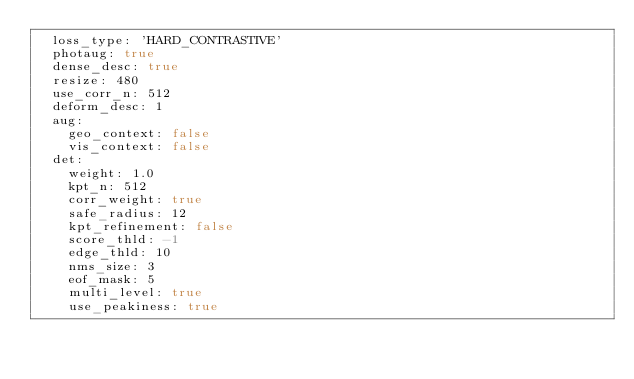<code> <loc_0><loc_0><loc_500><loc_500><_YAML_>  loss_type: 'HARD_CONTRASTIVE'
  photaug: true
  dense_desc: true
  resize: 480
  use_corr_n: 512
  deform_desc: 1
  aug:
    geo_context: false
    vis_context: false
  det:
    weight: 1.0
    kpt_n: 512 
    corr_weight: true
    safe_radius: 12
    kpt_refinement: false
    score_thld: -1
    edge_thld: 10
    nms_size: 3
    eof_mask: 5
    multi_level: true
    use_peakiness: true</code> 